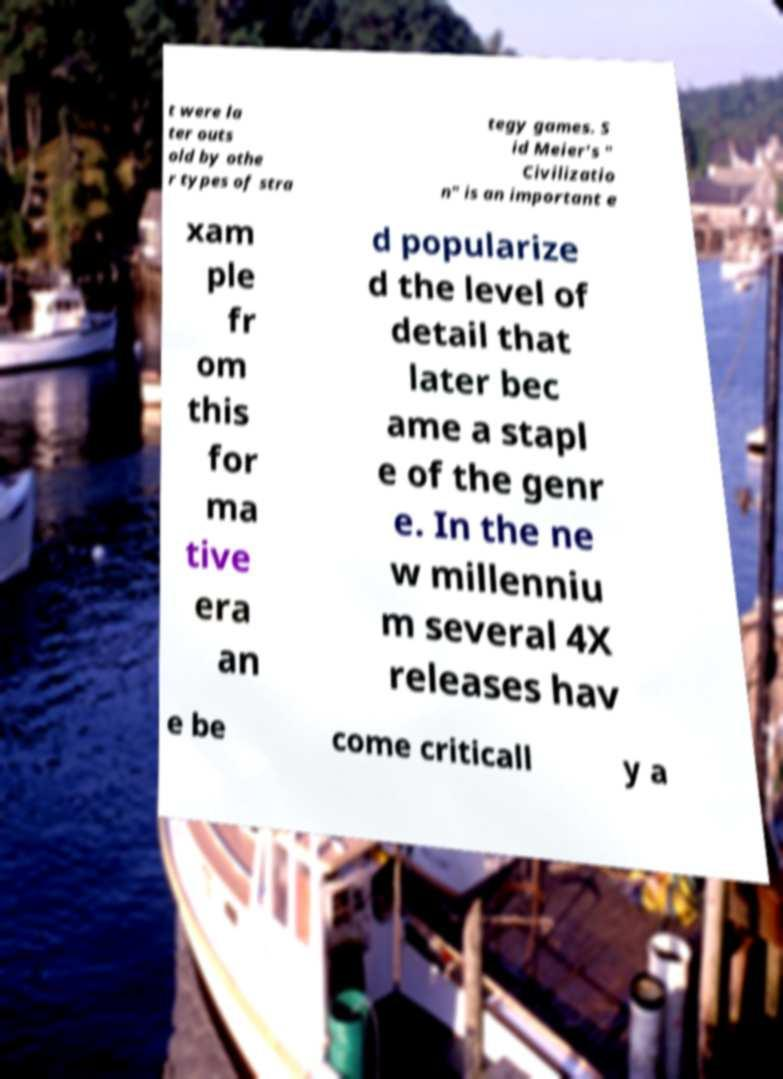I need the written content from this picture converted into text. Can you do that? t were la ter outs old by othe r types of stra tegy games. S id Meier's " Civilizatio n" is an important e xam ple fr om this for ma tive era an d popularize d the level of detail that later bec ame a stapl e of the genr e. In the ne w millenniu m several 4X releases hav e be come criticall y a 